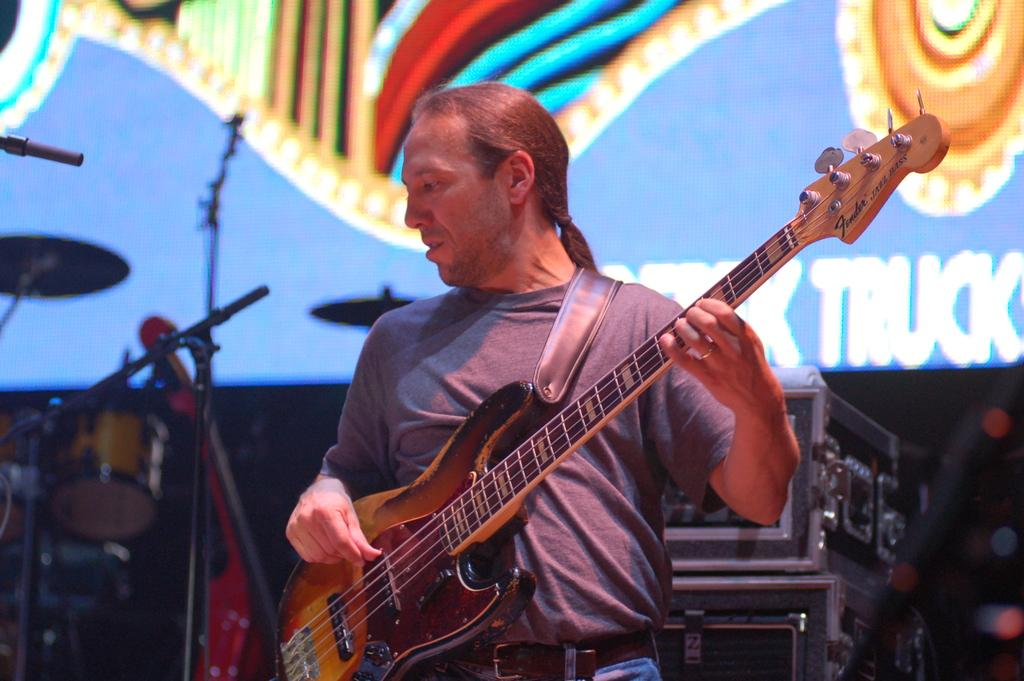What is the man in the image doing? The man is playing a guitar in the image. How is the man positioned in the image? The man is standing in the image. What can be seen in the background of the image? There is a screen in the background of the image. What other objects are present in the image besides the man and the screen? Musical instruments are present in the image. What type of mint is growing on the man's guitar in the image? There is no mint growing on the man's guitar in the image; it is a guitar being played by the man. 